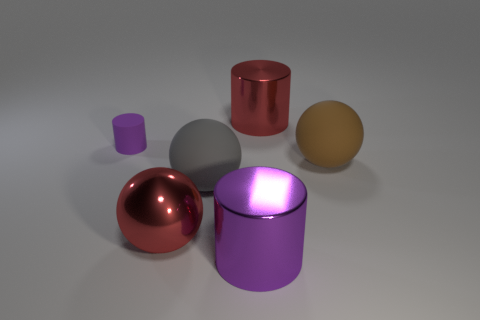What size is the red shiny thing that is to the right of the red object that is in front of the red shiny cylinder?
Provide a succinct answer. Large. What color is the big sphere that is made of the same material as the gray thing?
Offer a very short reply. Brown. What number of purple objects are the same size as the brown matte object?
Offer a terse response. 1. How many purple objects are either tiny shiny spheres or cylinders?
Provide a succinct answer. 2. How many things are gray matte objects or large metallic things on the right side of the red ball?
Your response must be concise. 3. There is a red thing to the right of the metal ball; what is it made of?
Provide a short and direct response. Metal. What shape is the brown thing that is the same size as the red shiny ball?
Keep it short and to the point. Sphere. Are there any other gray rubber objects of the same shape as the gray object?
Your response must be concise. No. Do the large gray ball and the red thing behind the big brown ball have the same material?
Provide a succinct answer. No. What is the material of the sphere that is to the right of the purple cylinder right of the tiny object?
Your answer should be very brief. Rubber. 